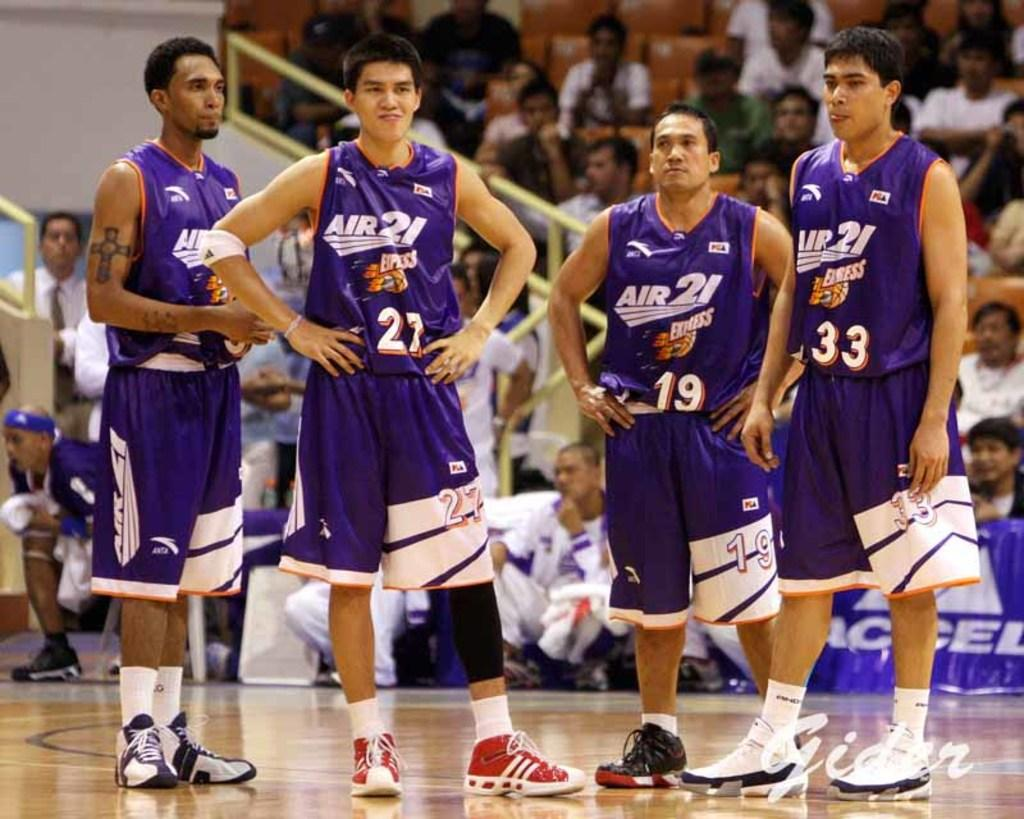<image>
Create a compact narrative representing the image presented. Four basketball players have on purple Air21 uniforms. 